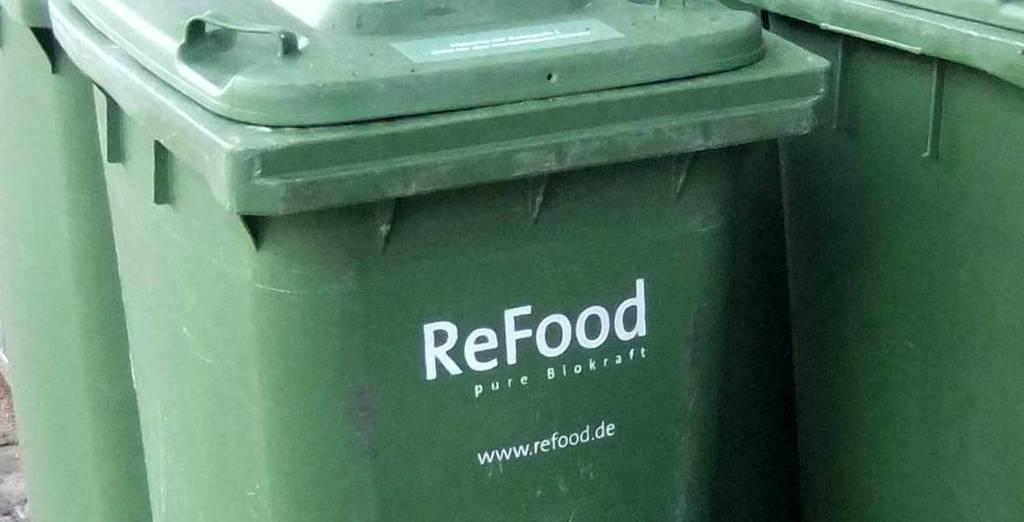Provide a one-sentence caption for the provided image. A large green trash container with the word ReFood written on it. 